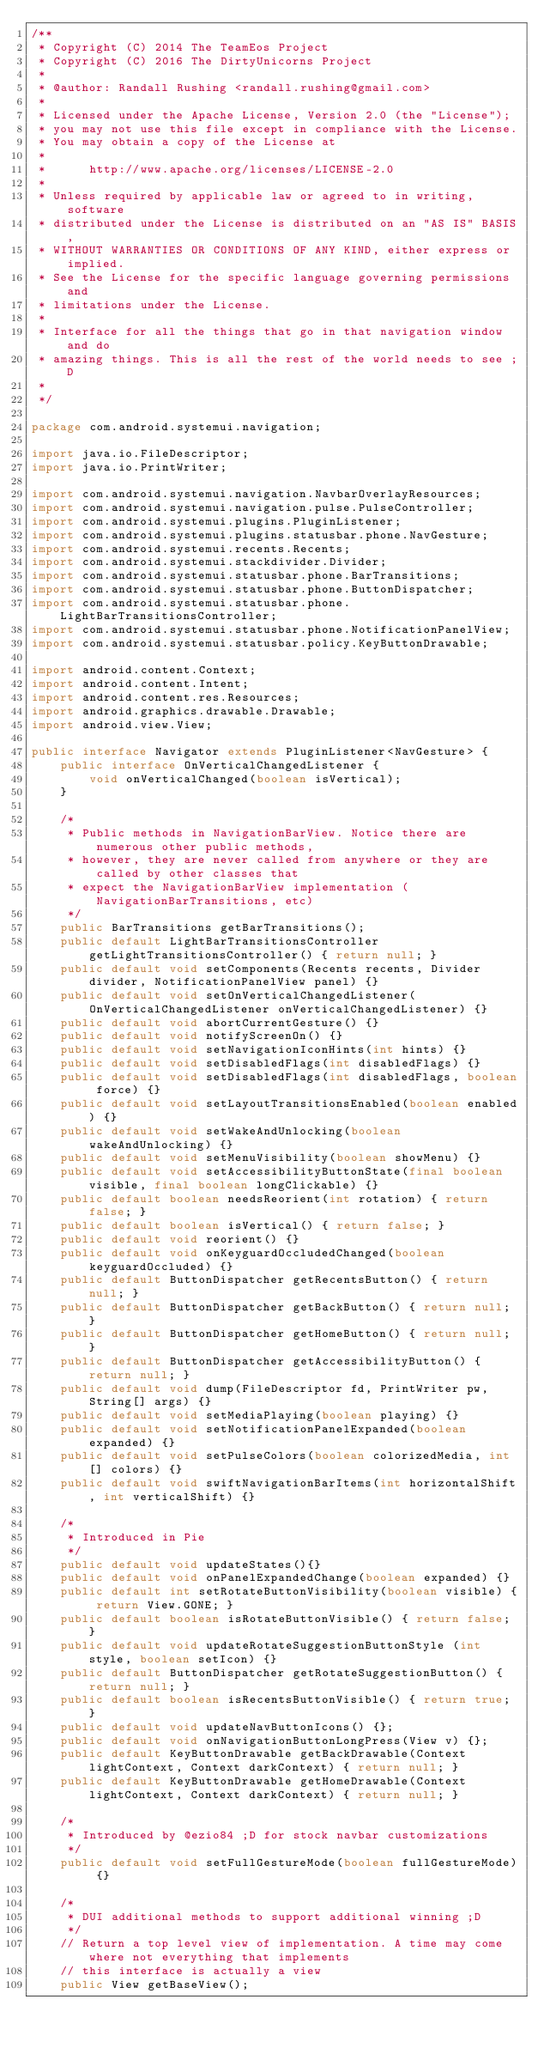Convert code to text. <code><loc_0><loc_0><loc_500><loc_500><_Java_>/**
 * Copyright (C) 2014 The TeamEos Project
 * Copyright (C) 2016 The DirtyUnicorns Project
 * 
 * @author: Randall Rushing <randall.rushing@gmail.com>
 *
 * Licensed under the Apache License, Version 2.0 (the "License");
 * you may not use this file except in compliance with the License.
 * You may obtain a copy of the License at
 *
 *      http://www.apache.org/licenses/LICENSE-2.0
 *
 * Unless required by applicable law or agreed to in writing, software
 * distributed under the License is distributed on an "AS IS" BASIS,
 * WITHOUT WARRANTIES OR CONDITIONS OF ANY KIND, either express or implied.
 * See the License for the specific language governing permissions and
 * limitations under the License.
 * 
 * Interface for all the things that go in that navigation window and do
 * amazing things. This is all the rest of the world needs to see ;D
 * 
 */

package com.android.systemui.navigation;

import java.io.FileDescriptor;
import java.io.PrintWriter;

import com.android.systemui.navigation.NavbarOverlayResources;
import com.android.systemui.navigation.pulse.PulseController;
import com.android.systemui.plugins.PluginListener;
import com.android.systemui.plugins.statusbar.phone.NavGesture;
import com.android.systemui.recents.Recents;
import com.android.systemui.stackdivider.Divider;
import com.android.systemui.statusbar.phone.BarTransitions;
import com.android.systemui.statusbar.phone.ButtonDispatcher;
import com.android.systemui.statusbar.phone.LightBarTransitionsController;
import com.android.systemui.statusbar.phone.NotificationPanelView;
import com.android.systemui.statusbar.policy.KeyButtonDrawable;

import android.content.Context;
import android.content.Intent;
import android.content.res.Resources;
import android.graphics.drawable.Drawable;
import android.view.View;

public interface Navigator extends PluginListener<NavGesture> {
    public interface OnVerticalChangedListener {
        void onVerticalChanged(boolean isVertical);
    }

    /*
     * Public methods in NavigationBarView. Notice there are numerous other public methods,
     * however, they are never called from anywhere or they are called by other classes that
     * expect the NavigationBarView implementation (NavigationBarTransitions, etc)
     */
    public BarTransitions getBarTransitions();
    public default LightBarTransitionsController getLightTransitionsController() { return null; }
    public default void setComponents(Recents recents, Divider divider, NotificationPanelView panel) {}
    public default void setOnVerticalChangedListener(OnVerticalChangedListener onVerticalChangedListener) {}
    public default void abortCurrentGesture() {}
    public default void notifyScreenOn() {}
    public default void setNavigationIconHints(int hints) {}
    public default void setDisabledFlags(int disabledFlags) {}
    public default void setDisabledFlags(int disabledFlags, boolean force) {}
    public default void setLayoutTransitionsEnabled(boolean enabled) {}
    public default void setWakeAndUnlocking(boolean wakeAndUnlocking) {}
    public default void setMenuVisibility(boolean showMenu) {}
    public default void setAccessibilityButtonState(final boolean visible, final boolean longClickable) {}
    public default boolean needsReorient(int rotation) { return false; }
    public default boolean isVertical() { return false; }
    public default void reorient() {}
    public default void onKeyguardOccludedChanged(boolean keyguardOccluded) {}
    public default ButtonDispatcher getRecentsButton() { return null; }
    public default ButtonDispatcher getBackButton() { return null; }
    public default ButtonDispatcher getHomeButton() { return null; }
    public default ButtonDispatcher getAccessibilityButton() { return null; }
    public default void dump(FileDescriptor fd, PrintWriter pw, String[] args) {}
    public default void setMediaPlaying(boolean playing) {}
    public default void setNotificationPanelExpanded(boolean expanded) {}
    public default void setPulseColors(boolean colorizedMedia, int[] colors) {}
    public default void swiftNavigationBarItems(int horizontalShift, int verticalShift) {}

    /*
     * Introduced in Pie
     */
    public default void updateStates(){}
    public default void onPanelExpandedChange(boolean expanded) {}
    public default int setRotateButtonVisibility(boolean visible) { return View.GONE; }
    public default boolean isRotateButtonVisible() { return false; }
    public default void updateRotateSuggestionButtonStyle (int style, boolean setIcon) {}
    public default ButtonDispatcher getRotateSuggestionButton() { return null; }
    public default boolean isRecentsButtonVisible() { return true; }
    public default void updateNavButtonIcons() {};
    public default void onNavigationButtonLongPress(View v) {};
    public default KeyButtonDrawable getBackDrawable(Context lightContext, Context darkContext) { return null; }
    public default KeyButtonDrawable getHomeDrawable(Context lightContext, Context darkContext) { return null; }

    /*
     * Introduced by @ezio84 ;D for stock navbar customizations
     */
    public default void setFullGestureMode(boolean fullGestureMode) {}

    /*
     * DUI additional methods to support additional winning ;D
     */
    // Return a top level view of implementation. A time may come where not everything that implements
    // this interface is actually a view
    public View getBaseView();
</code> 